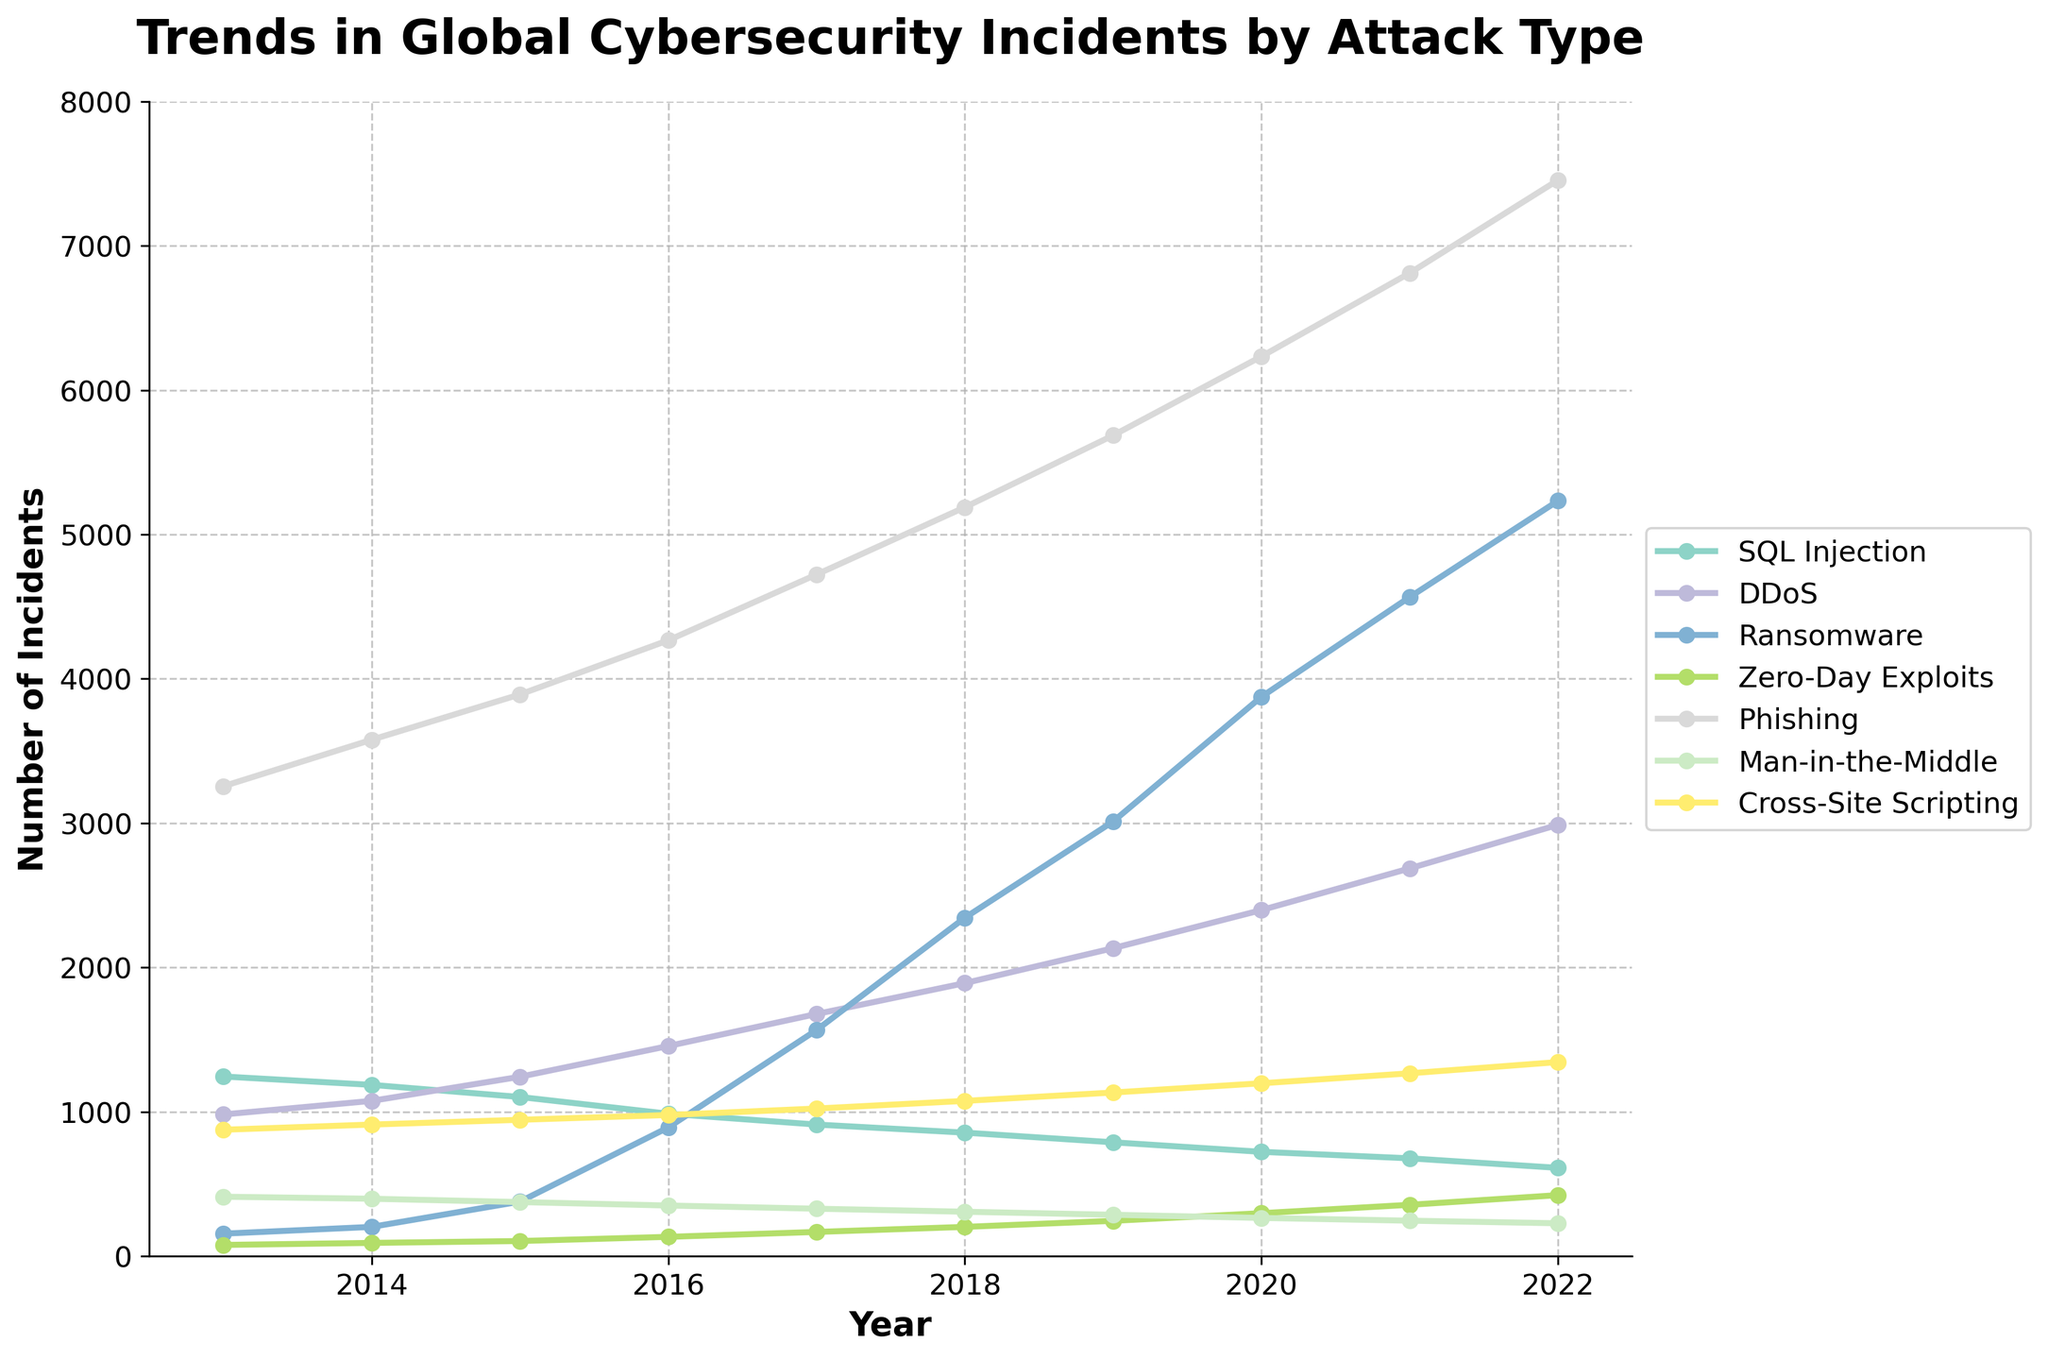Which attack type saw the highest increase in incidents between 2013 and 2022? To determine the attack type with the highest increase in incidents, subtract the number of incidents in 2013 from the number in 2022 for each attack type. The attack with the greatest positive difference is Ransomware (5234 - 156 = 5078).
Answer: Ransomware Which attack type experienced a decline in incidents over the decade? Examine the data for any attack type where the incidents decreased from 2013 to 2022. SQL Injection incidents decreased from 1245 in 2013 to 612 in 2022.
Answer: SQL Injection How many more DDoS incidents were there compared to Phishing incidents in 2022? Subtract the number of Phishing incidents from the number of DDoS incidents in 2022. 2989 - 7456 = -4467, showing that Phishing incidents are higher. Compare these values directly.
Answer: 4467 more Phishing incidents Which year did Ransomware incidents surpass 2000? Review the Ransomware data to find the year the incidents first exceed 2000. In 2018, the incidents were 2345.
Answer: 2018 From 2016 to 2019, which attack type had the greatest increase in incidents? Calculate the change in incidents between 2016 and 2019 for each attack type. Ransomware increased from 892 to 3012, an increase of 2120 incidents, the highest change.
Answer: Ransomware Among Man-in-the-Middle and Cross-Site Scripting, which attack type had fewer incidents in 2017? Compare the number of incidents in 2017. Man-in-the-Middle had 329 incidents, and Cross-Site Scripting had 1023 incidents.
Answer: Man-in-the-Middle How did the number of Zero-Day Exploits change between 2018 and 2020? Subtract the incidents of Zero-Day Exploits in 2018 from those in 2020. 298 - 203 equals an increase of 95 incidents.
Answer: Increased by 95 What was the average number of SQL Injection incidents per year over the decade? Sum the SQL Injection incidents from 2013 to 2022 and divide by the number of years, (1245 + 1187 + 1103 + 987 + 912 + 856 + 789 + 723 + 678 + 612) / 10 = 9092 / 10 = 909.2
Answer: 909.2 How does the trend of SQL Injection incidents compare to Phishing incidents from 2013 to 2022? Examine both trends across the years. SQL Injection incidents consistently decrease from 1245 to 612, while Phishing incidents increase from 3256 to 7456.
Answer: SQL Injection decreased, Phishing increased 